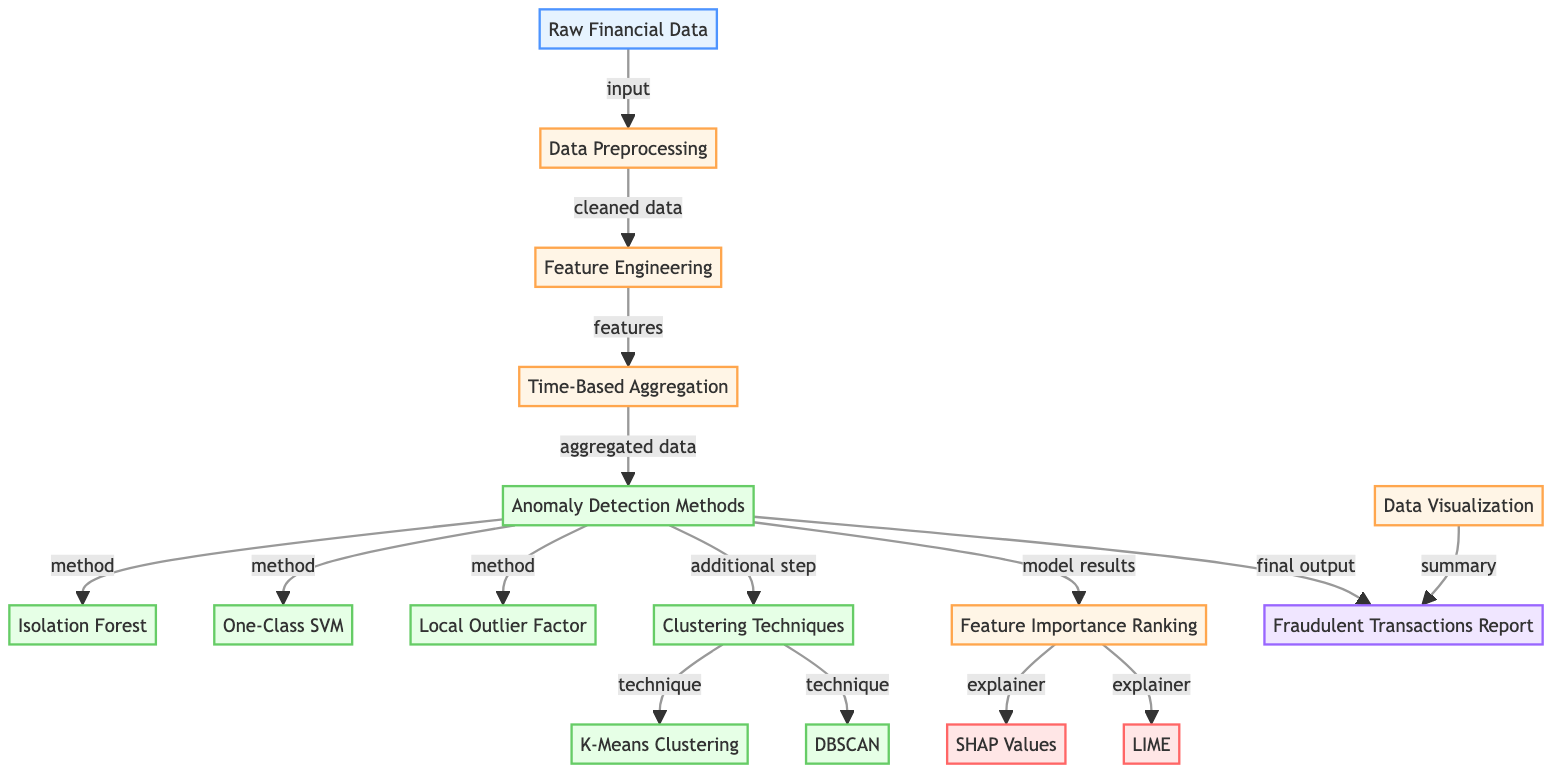What is the first stage in the diagram? The first stage represented in the diagram is "Raw Financial Data". This is identified as the starting node.
Answer: Raw Financial Data How many anomaly detection methods are presented in the diagram? The diagram shows three distinct anomaly detection methods: Isolation Forest, One-Class SVM, and Local Outlier Factor. These are located under the "Anomaly Detection Methods" node.
Answer: Three What is the output of the diagram? The final output of the diagram is the "Fraudulent Transactions Report" node, which is shown at the bottom of the flow.
Answer: Fraudulent Transactions Report Which model is mentioned last in the anomaly detection methods? The last model mentioned under the anomaly detection methods is "Local Outlier Factor". It follows the order of listing for anomaly detection methods.
Answer: Local Outlier Factor What method is used for explaining feature importance according to the diagram? Two methods are indicated for explaining feature importance: SHAP Values and LIME. They are listed under the "Feature Importance Ranking" node.
Answer: SHAP Values and LIME Which step comes after "Time-Based Aggregation"? The step that comes next after "Time-Based Aggregation" is "Anomaly Detection Methods", as indicated by the directional arrow connecting these two nodes.
Answer: Anomaly Detection Methods What is the last process node before the final output? The last process node before reaching the final output is "Data Visualization". This step is crucial for summarizing and presenting the results in the output.
Answer: Data Visualization How do the clustering techniques relate to anomaly detection methods? Clustering techniques are an additional step listed under the "Anomaly Detection Methods", indicating they complement these methods in identifying fraudulent transactions.
Answer: Clustering Techniques complement anomaly detection methods 